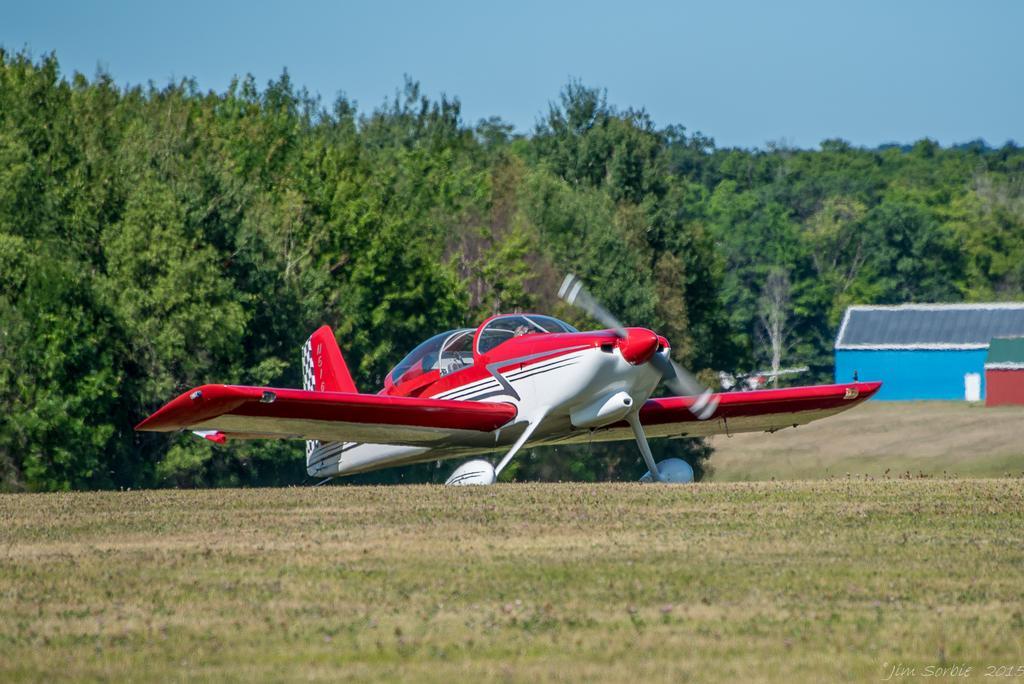How would you summarize this image in a sentence or two? In this image we can see a plane on the ground. In the background there are trees, houses and sky. 